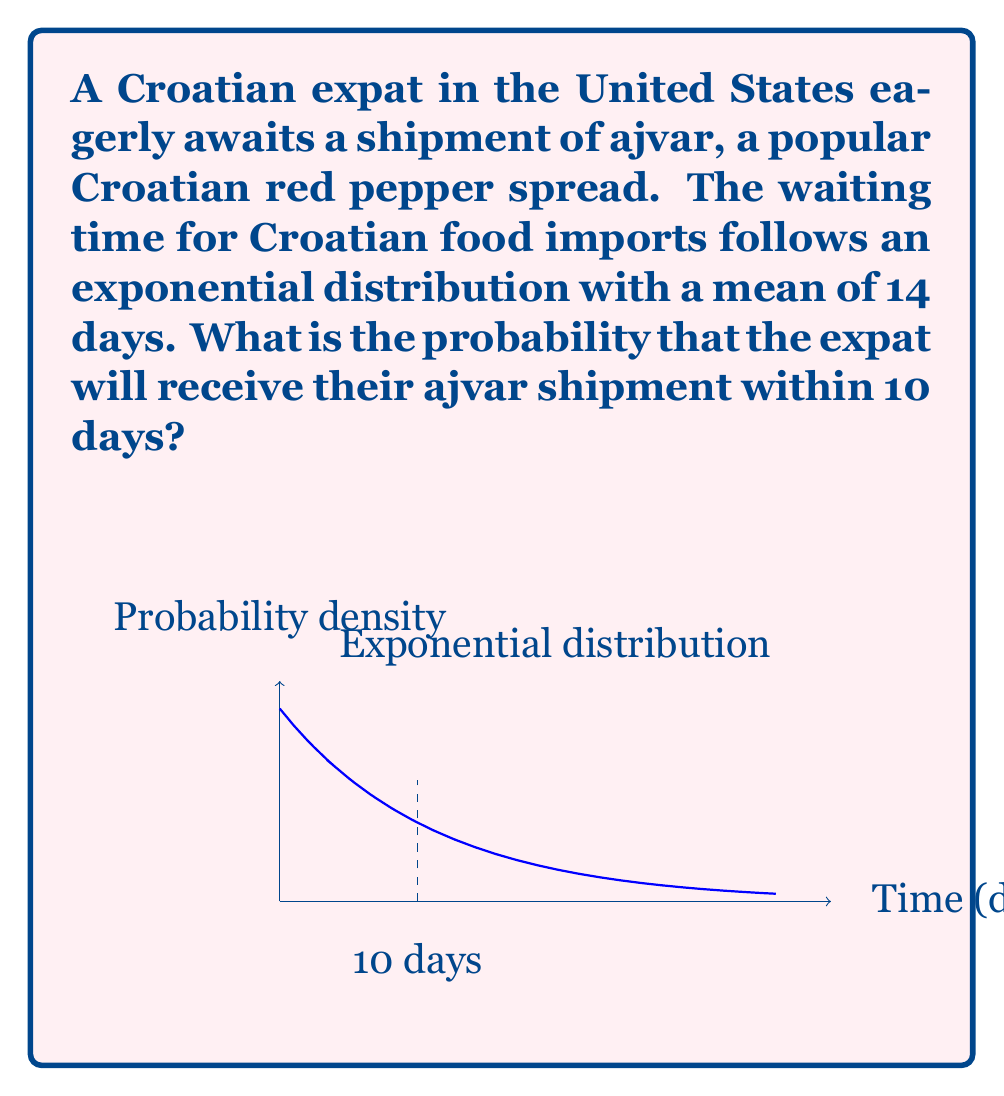Could you help me with this problem? Let's approach this step-by-step:

1) The exponential distribution is given by the probability density function:
   $$f(x) = \lambda e^{-\lambda x}$$
   where $\lambda$ is the rate parameter.

2) We're given that the mean waiting time is 14 days. For an exponential distribution, the mean is $\frac{1}{\lambda}$. So:
   $$\frac{1}{\lambda} = 14$$
   $$\lambda = \frac{1}{14}$$

3) We want to find the probability of receiving the shipment within 10 days. This is equivalent to finding the cumulative distribution function (CDF) at x = 10:
   $$P(X \leq 10) = 1 - e^{-\lambda x}$$

4) Substituting our values:
   $$P(X \leq 10) = 1 - e^{-\frac{1}{14} \cdot 10}$$

5) Simplifying:
   $$P(X \leq 10) = 1 - e^{-\frac{5}{7}}$$

6) Calculating:
   $$P(X \leq 10) \approx 0.5101$$

Therefore, the probability of receiving the ajvar shipment within 10 days is approximately 0.5101 or 51.01%.
Answer: $1 - e^{-\frac{5}{7}} \approx 0.5101$ or 51.01% 